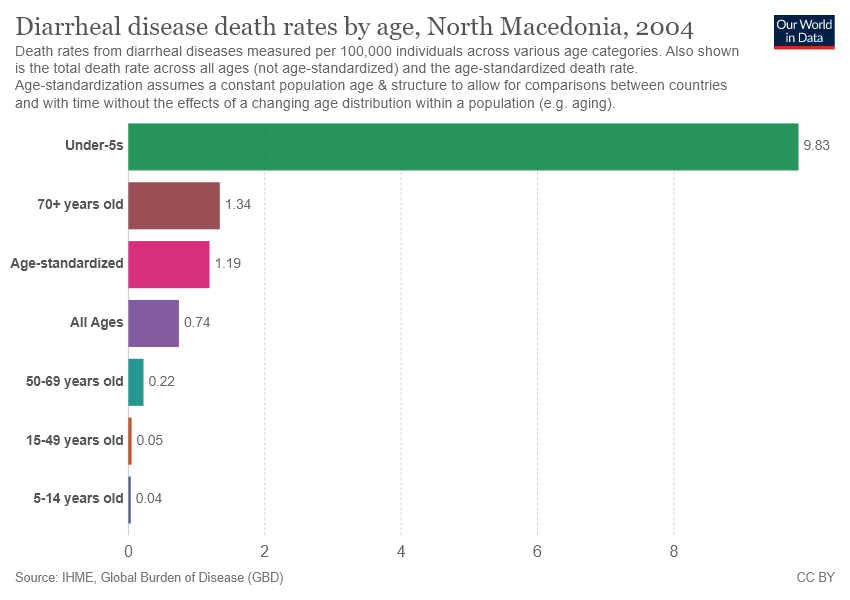What is the significance of having an age-standardized category in this graph? The age-standardized category provides a death rate that accounts for age distribution differences within the population. This allows for more accurate comparisons between different countries or populations, regardless of their age structure differences. How does the age structure impact the interpretation of health data? Age structure can significantly impact health metrics, as older populations might naturally show higher rates of certain diseases. Adjusting for age structure allows for clearer interpretation of data, showing whether higher rates are due to the population’s age or other factors. 